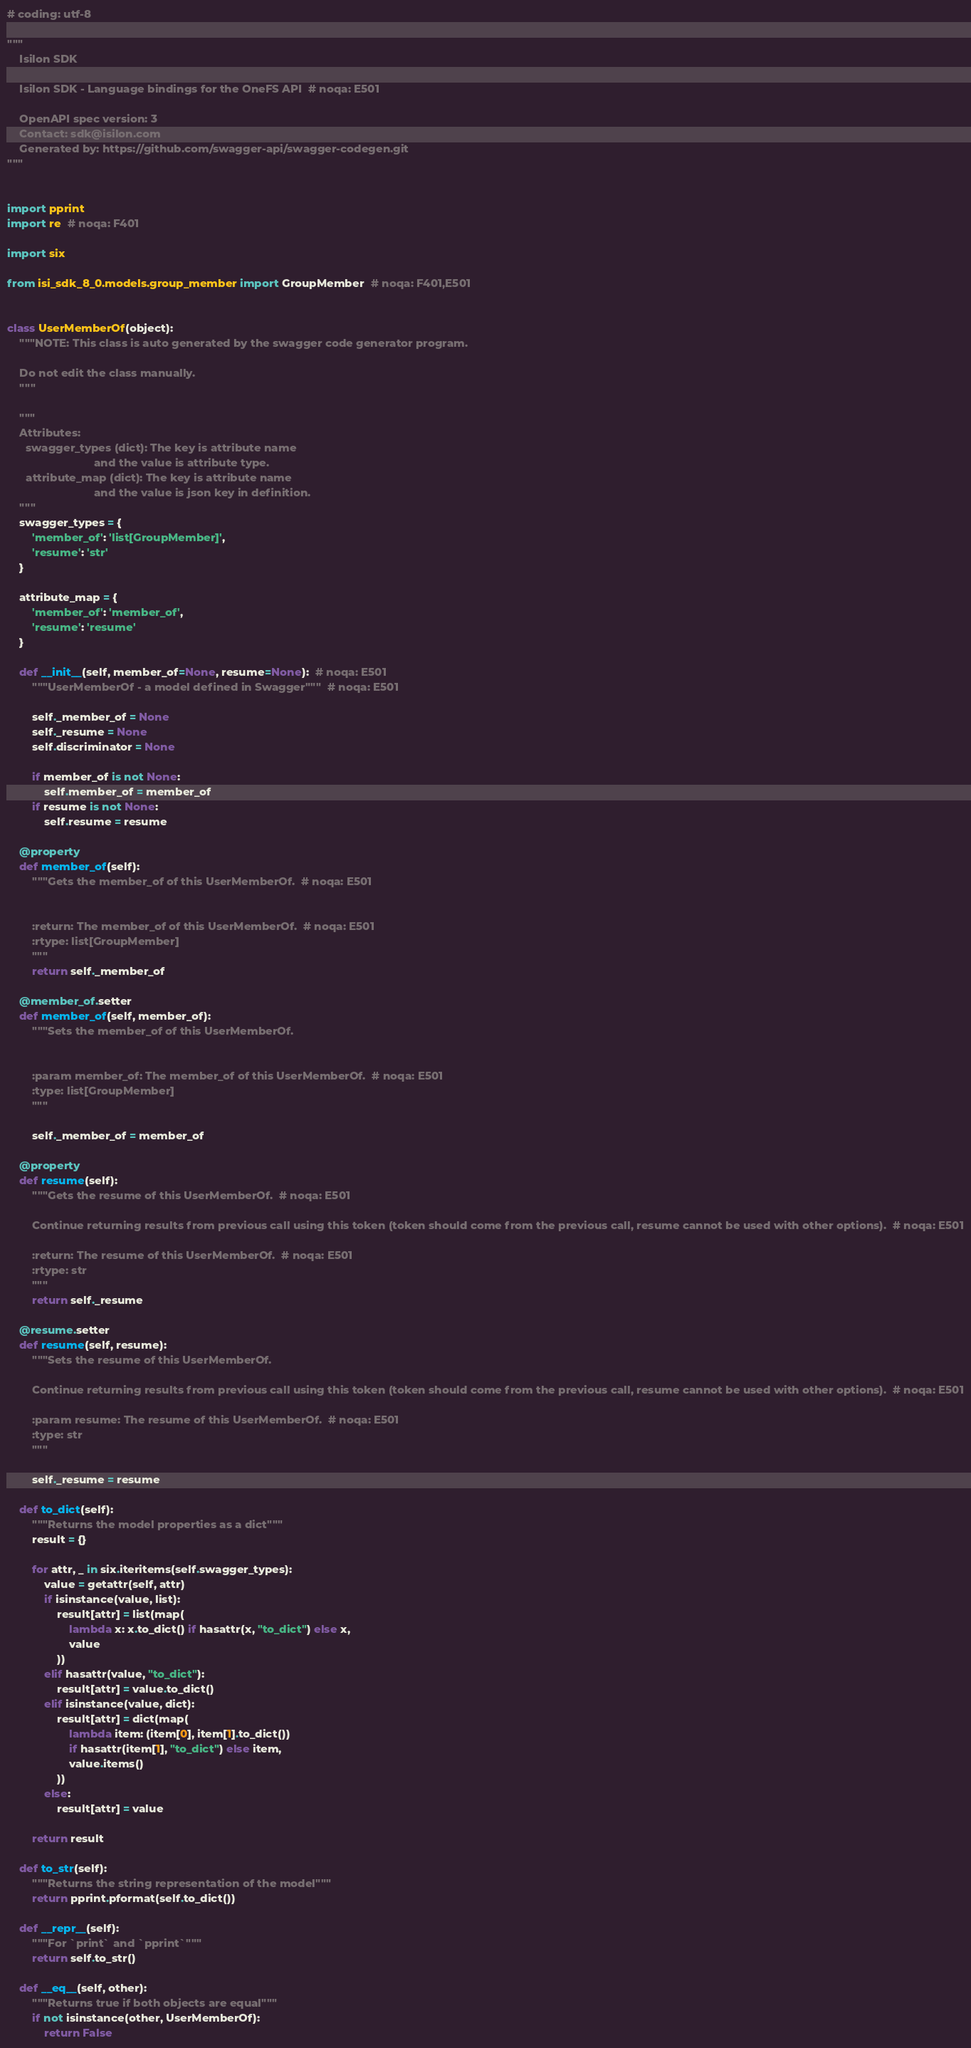<code> <loc_0><loc_0><loc_500><loc_500><_Python_># coding: utf-8

"""
    Isilon SDK

    Isilon SDK - Language bindings for the OneFS API  # noqa: E501

    OpenAPI spec version: 3
    Contact: sdk@isilon.com
    Generated by: https://github.com/swagger-api/swagger-codegen.git
"""


import pprint
import re  # noqa: F401

import six

from isi_sdk_8_0.models.group_member import GroupMember  # noqa: F401,E501


class UserMemberOf(object):
    """NOTE: This class is auto generated by the swagger code generator program.

    Do not edit the class manually.
    """

    """
    Attributes:
      swagger_types (dict): The key is attribute name
                            and the value is attribute type.
      attribute_map (dict): The key is attribute name
                            and the value is json key in definition.
    """
    swagger_types = {
        'member_of': 'list[GroupMember]',
        'resume': 'str'
    }

    attribute_map = {
        'member_of': 'member_of',
        'resume': 'resume'
    }

    def __init__(self, member_of=None, resume=None):  # noqa: E501
        """UserMemberOf - a model defined in Swagger"""  # noqa: E501

        self._member_of = None
        self._resume = None
        self.discriminator = None

        if member_of is not None:
            self.member_of = member_of
        if resume is not None:
            self.resume = resume

    @property
    def member_of(self):
        """Gets the member_of of this UserMemberOf.  # noqa: E501


        :return: The member_of of this UserMemberOf.  # noqa: E501
        :rtype: list[GroupMember]
        """
        return self._member_of

    @member_of.setter
    def member_of(self, member_of):
        """Sets the member_of of this UserMemberOf.


        :param member_of: The member_of of this UserMemberOf.  # noqa: E501
        :type: list[GroupMember]
        """

        self._member_of = member_of

    @property
    def resume(self):
        """Gets the resume of this UserMemberOf.  # noqa: E501

        Continue returning results from previous call using this token (token should come from the previous call, resume cannot be used with other options).  # noqa: E501

        :return: The resume of this UserMemberOf.  # noqa: E501
        :rtype: str
        """
        return self._resume

    @resume.setter
    def resume(self, resume):
        """Sets the resume of this UserMemberOf.

        Continue returning results from previous call using this token (token should come from the previous call, resume cannot be used with other options).  # noqa: E501

        :param resume: The resume of this UserMemberOf.  # noqa: E501
        :type: str
        """

        self._resume = resume

    def to_dict(self):
        """Returns the model properties as a dict"""
        result = {}

        for attr, _ in six.iteritems(self.swagger_types):
            value = getattr(self, attr)
            if isinstance(value, list):
                result[attr] = list(map(
                    lambda x: x.to_dict() if hasattr(x, "to_dict") else x,
                    value
                ))
            elif hasattr(value, "to_dict"):
                result[attr] = value.to_dict()
            elif isinstance(value, dict):
                result[attr] = dict(map(
                    lambda item: (item[0], item[1].to_dict())
                    if hasattr(item[1], "to_dict") else item,
                    value.items()
                ))
            else:
                result[attr] = value

        return result

    def to_str(self):
        """Returns the string representation of the model"""
        return pprint.pformat(self.to_dict())

    def __repr__(self):
        """For `print` and `pprint`"""
        return self.to_str()

    def __eq__(self, other):
        """Returns true if both objects are equal"""
        if not isinstance(other, UserMemberOf):
            return False
</code> 